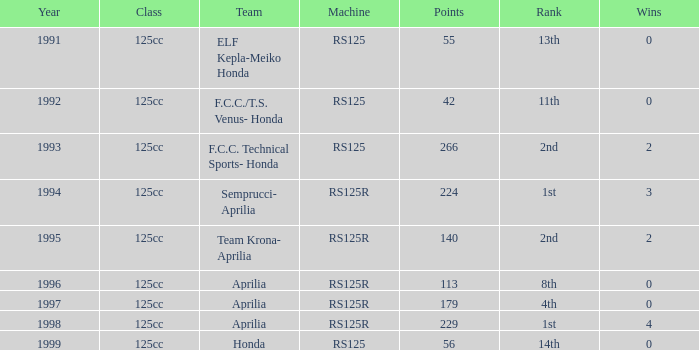Which year had a team of Aprilia and a rank of 4th? 1997.0. 